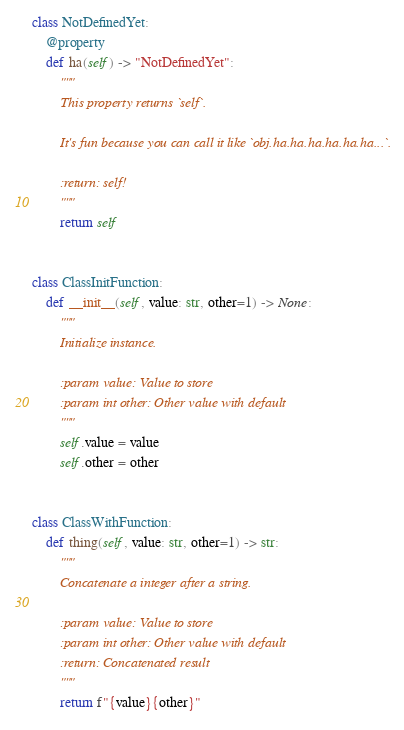Convert code to text. <code><loc_0><loc_0><loc_500><loc_500><_Python_>class NotDefinedYet:
    @property
    def ha(self) -> "NotDefinedYet":
        """
        This property returns `self`.

        It's fun because you can call it like `obj.ha.ha.ha.ha.ha.ha...`.

        :return: self!
        """
        return self


class ClassInitFunction:
    def __init__(self, value: str, other=1) -> None:
        """
        Initialize instance.

        :param value: Value to store
        :param int other: Other value with default
        """
        self.value = value
        self.other = other


class ClassWithFunction:
    def thing(self, value: str, other=1) -> str:
        """
        Concatenate a integer after a string.

        :param value: Value to store
        :param int other: Other value with default
        :return: Concatenated result
        """
        return f"{value}{other}"
</code> 